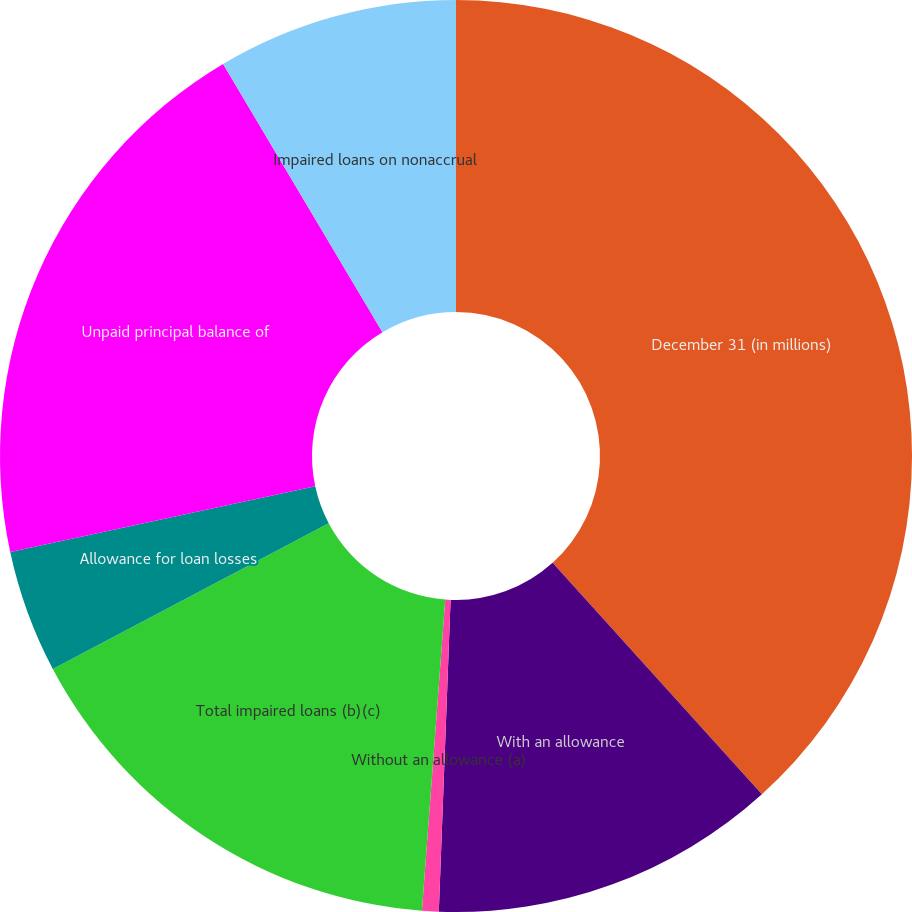Convert chart. <chart><loc_0><loc_0><loc_500><loc_500><pie_chart><fcel>December 31 (in millions)<fcel>With an allowance<fcel>Without an allowance (a)<fcel>Total impaired loans (b)(c)<fcel>Allowance for loan losses<fcel>Unpaid principal balance of<fcel>Impaired loans on nonaccrual<nl><fcel>38.29%<fcel>12.3%<fcel>0.59%<fcel>16.07%<fcel>4.36%<fcel>19.84%<fcel>8.53%<nl></chart> 